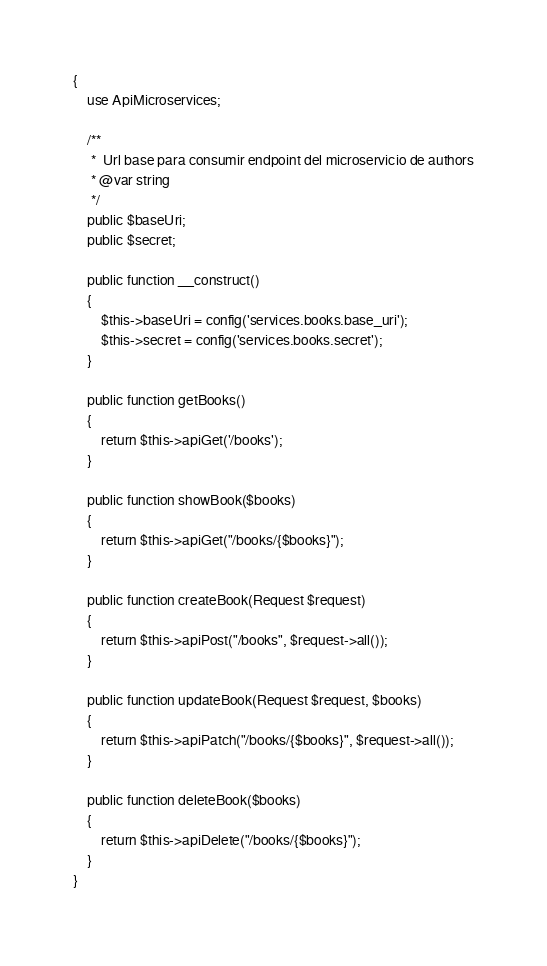Convert code to text. <code><loc_0><loc_0><loc_500><loc_500><_PHP_>{
    use ApiMicroservices;

    /**
     *  Url base para consumir endpoint del microservicio de authors
     * @var string
     */
    public $baseUri;
    public $secret;

    public function __construct()
    {
        $this->baseUri = config('services.books.base_uri');
        $this->secret = config('services.books.secret');
    }

    public function getBooks()
    {
        return $this->apiGet('/books');
    }

    public function showBook($books)
    {
        return $this->apiGet("/books/{$books}");
    }

    public function createBook(Request $request)
    {
        return $this->apiPost("/books", $request->all());
    }

    public function updateBook(Request $request, $books)
    {
        return $this->apiPatch("/books/{$books}", $request->all());
    }

    public function deleteBook($books)
    {
        return $this->apiDelete("/books/{$books}");
    }
}
</code> 